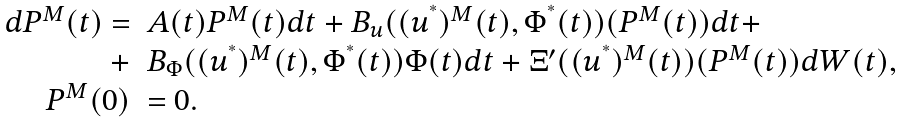<formula> <loc_0><loc_0><loc_500><loc_500>\begin{array} { r l } d P ^ { M } ( t ) = & A ( t ) P ^ { M } ( t ) d t + B _ { u } ( ( u ^ { ^ { * } } ) ^ { M } ( t ) , \Phi ^ { ^ { * } } ( t ) ) ( P ^ { M } ( t ) ) d t + \\ + & B _ { \Phi } ( ( u ^ { ^ { * } } ) ^ { M } ( t ) , \Phi ^ { ^ { * } } ( t ) ) \Phi ( t ) d t + \Xi ^ { \prime } ( ( u ^ { ^ { * } } ) ^ { M } ( t ) ) ( P ^ { M } ( t ) ) d W ( t ) , \\ P ^ { M } ( 0 ) & = 0 . \end{array}</formula> 